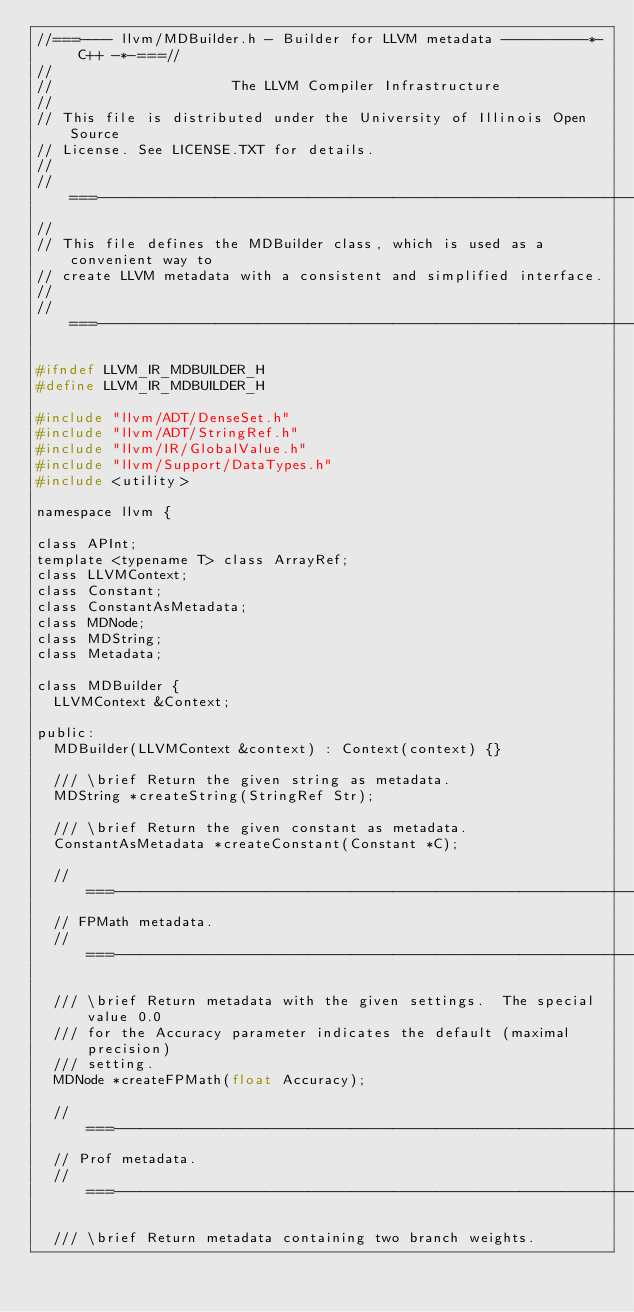Convert code to text. <code><loc_0><loc_0><loc_500><loc_500><_C_>//===---- llvm/MDBuilder.h - Builder for LLVM metadata ----------*- C++ -*-===//
//
//                     The LLVM Compiler Infrastructure
//
// This file is distributed under the University of Illinois Open Source
// License. See LICENSE.TXT for details.
//
//===----------------------------------------------------------------------===//
//
// This file defines the MDBuilder class, which is used as a convenient way to
// create LLVM metadata with a consistent and simplified interface.
//
//===----------------------------------------------------------------------===//

#ifndef LLVM_IR_MDBUILDER_H
#define LLVM_IR_MDBUILDER_H

#include "llvm/ADT/DenseSet.h"
#include "llvm/ADT/StringRef.h"
#include "llvm/IR/GlobalValue.h"
#include "llvm/Support/DataTypes.h"
#include <utility>

namespace llvm {

class APInt;
template <typename T> class ArrayRef;
class LLVMContext;
class Constant;
class ConstantAsMetadata;
class MDNode;
class MDString;
class Metadata;

class MDBuilder {
  LLVMContext &Context;

public:
  MDBuilder(LLVMContext &context) : Context(context) {}

  /// \brief Return the given string as metadata.
  MDString *createString(StringRef Str);

  /// \brief Return the given constant as metadata.
  ConstantAsMetadata *createConstant(Constant *C);

  //===------------------------------------------------------------------===//
  // FPMath metadata.
  //===------------------------------------------------------------------===//

  /// \brief Return metadata with the given settings.  The special value 0.0
  /// for the Accuracy parameter indicates the default (maximal precision)
  /// setting.
  MDNode *createFPMath(float Accuracy);

  //===------------------------------------------------------------------===//
  // Prof metadata.
  //===------------------------------------------------------------------===//

  /// \brief Return metadata containing two branch weights.</code> 